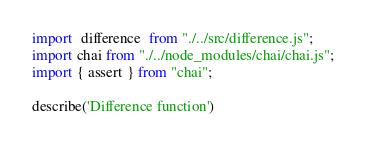<code> <loc_0><loc_0><loc_500><loc_500><_JavaScript_>import  difference  from "./../src/difference.js";
import chai from "./../node_modules/chai/chai.js";
import { assert } from "chai";

describe('Difference function')</code> 